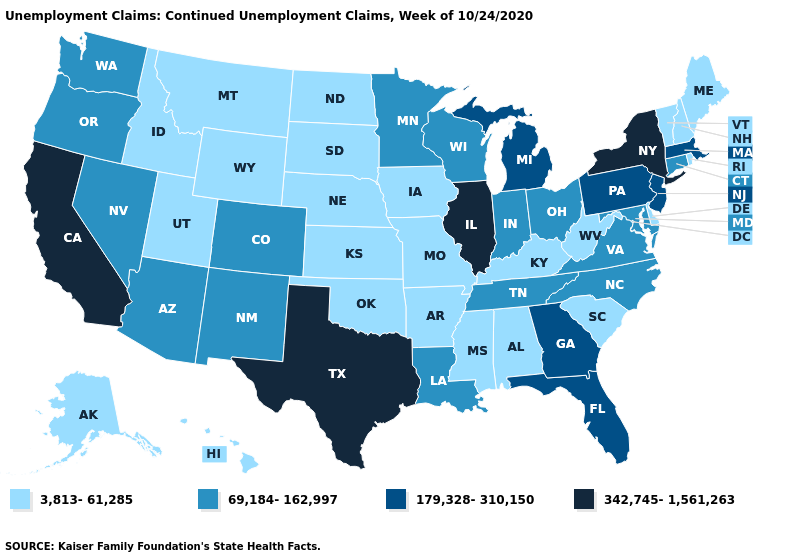Name the states that have a value in the range 69,184-162,997?
Short answer required. Arizona, Colorado, Connecticut, Indiana, Louisiana, Maryland, Minnesota, Nevada, New Mexico, North Carolina, Ohio, Oregon, Tennessee, Virginia, Washington, Wisconsin. What is the lowest value in the USA?
Keep it brief. 3,813-61,285. What is the value of New Hampshire?
Concise answer only. 3,813-61,285. Does Idaho have a lower value than Nevada?
Answer briefly. Yes. What is the highest value in the USA?
Write a very short answer. 342,745-1,561,263. What is the lowest value in states that border Pennsylvania?
Be succinct. 3,813-61,285. Does Utah have a higher value than North Carolina?
Write a very short answer. No. Does the map have missing data?
Keep it brief. No. Name the states that have a value in the range 3,813-61,285?
Be succinct. Alabama, Alaska, Arkansas, Delaware, Hawaii, Idaho, Iowa, Kansas, Kentucky, Maine, Mississippi, Missouri, Montana, Nebraska, New Hampshire, North Dakota, Oklahoma, Rhode Island, South Carolina, South Dakota, Utah, Vermont, West Virginia, Wyoming. Name the states that have a value in the range 69,184-162,997?
Concise answer only. Arizona, Colorado, Connecticut, Indiana, Louisiana, Maryland, Minnesota, Nevada, New Mexico, North Carolina, Ohio, Oregon, Tennessee, Virginia, Washington, Wisconsin. Which states hav the highest value in the Northeast?
Write a very short answer. New York. Name the states that have a value in the range 3,813-61,285?
Quick response, please. Alabama, Alaska, Arkansas, Delaware, Hawaii, Idaho, Iowa, Kansas, Kentucky, Maine, Mississippi, Missouri, Montana, Nebraska, New Hampshire, North Dakota, Oklahoma, Rhode Island, South Carolina, South Dakota, Utah, Vermont, West Virginia, Wyoming. Among the states that border California , which have the lowest value?
Keep it brief. Arizona, Nevada, Oregon. 